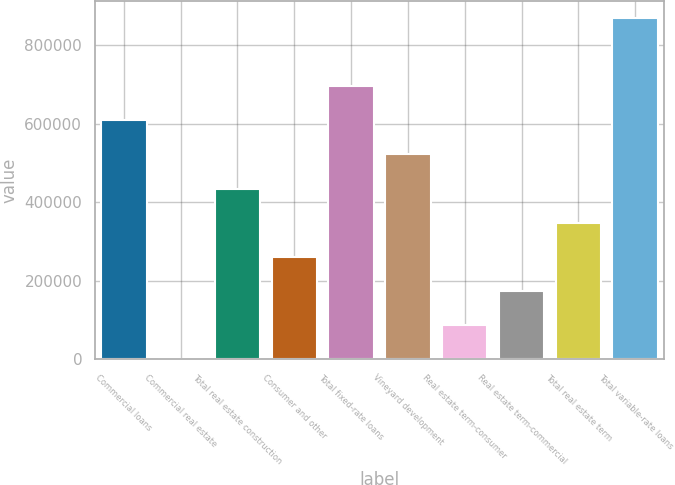<chart> <loc_0><loc_0><loc_500><loc_500><bar_chart><fcel>Commercial loans<fcel>Commercial real estate<fcel>Total real estate construction<fcel>Consumer and other<fcel>Total fixed-rate loans<fcel>Vineyard development<fcel>Real estate term-consumer<fcel>Real estate term-commercial<fcel>Total real estate term<fcel>Total variable-rate loans<nl><fcel>608442<fcel>50<fcel>434616<fcel>260789<fcel>695355<fcel>521529<fcel>86963.1<fcel>173876<fcel>347702<fcel>869181<nl></chart> 